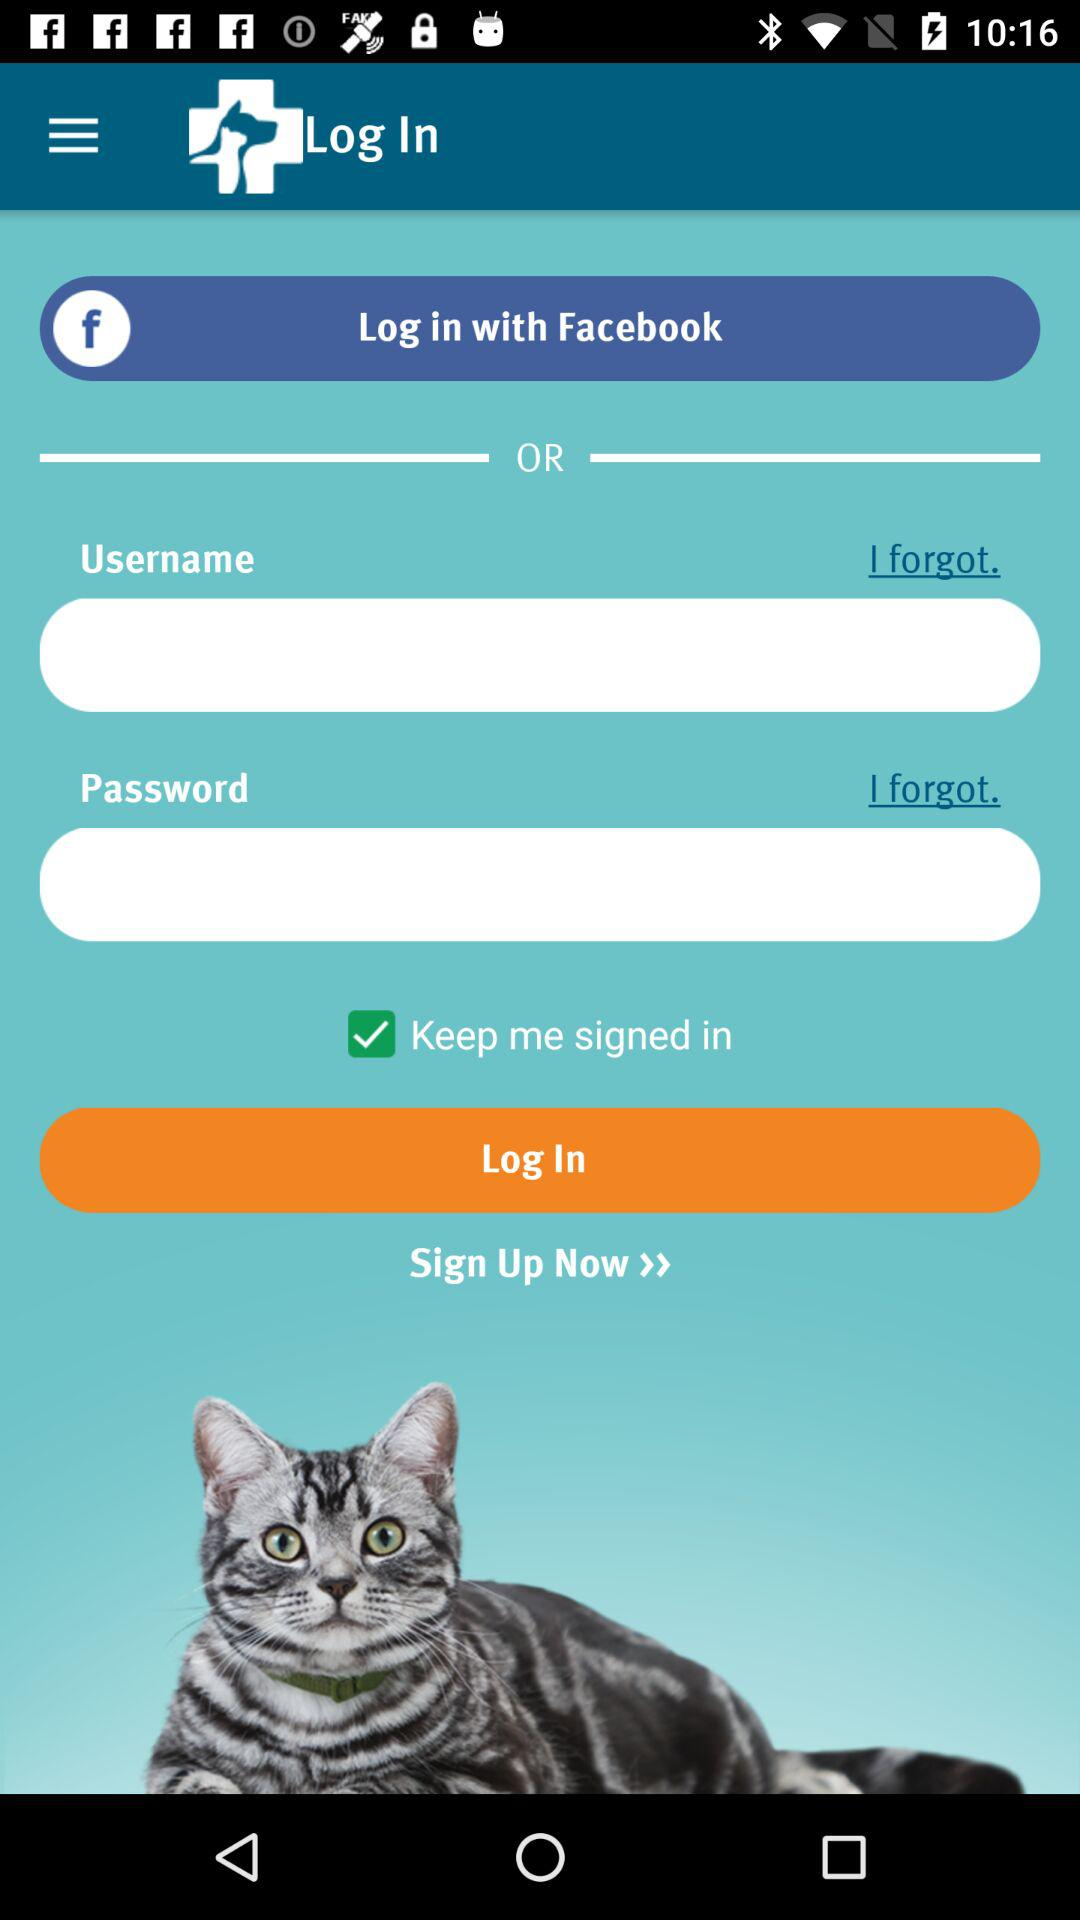What are the given login options? The given login options are "Facebook" and "Username". 